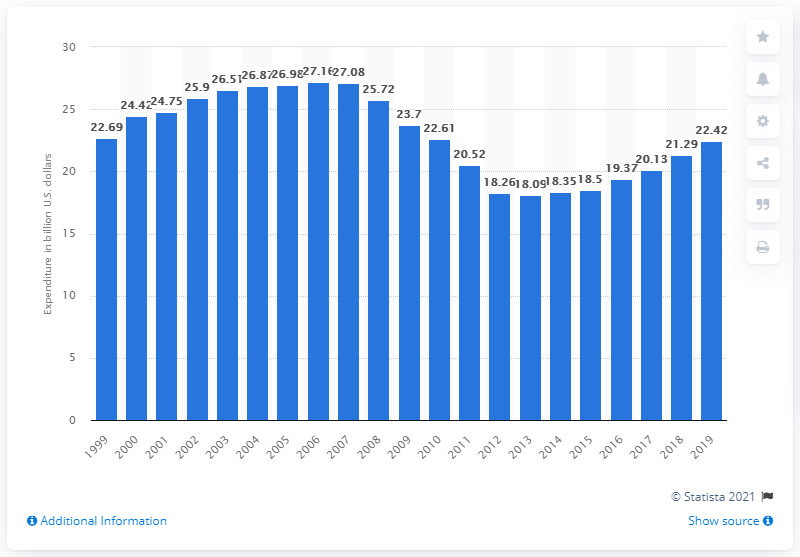Which year showed the highest expenditure on recreational books according to the data in the chart, and what can be inferred about consumer habits from that? The year 2009 posted the highest expenditure on recreational books, with consumers spending nearly $27.63 billion. This peak might indicate a strong economy or a particular interest in reading due to popular titles or trends during that year. It could also suggest that digital media hadn't yet fully displaced physical book sales. 